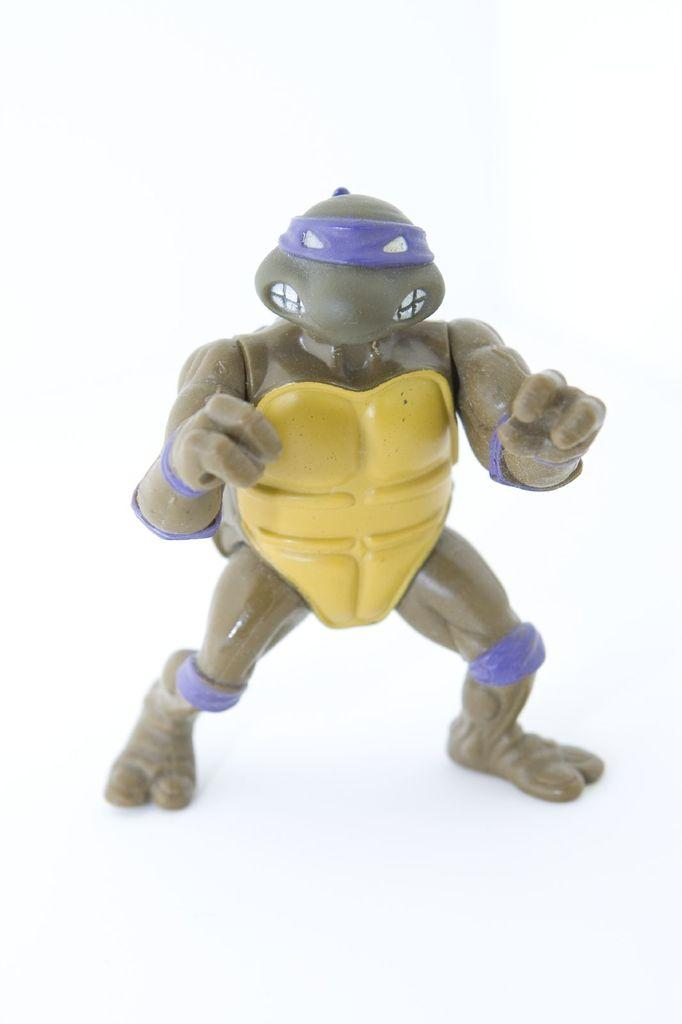What is the main subject of the image? There is a person in the image. What is the person doing in the image? The person is standing. What is the person holding in the image? The person is holding an object. What type of receipt can be seen in the person's hand in the image? There is no receipt visible in the person's hand in the image. What type of cannon is the person using in the image? There is no cannon present in the image. 